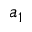Convert formula to latex. <formula><loc_0><loc_0><loc_500><loc_500>a _ { 1 }</formula> 